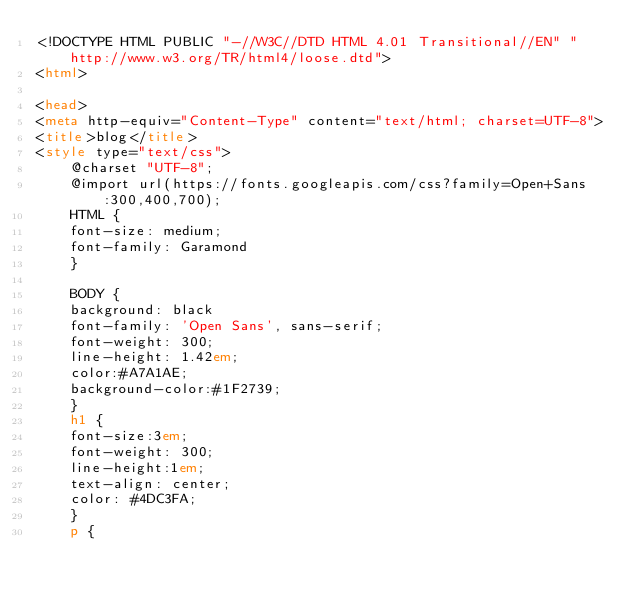<code> <loc_0><loc_0><loc_500><loc_500><_HTML_><!DOCTYPE HTML PUBLIC "-//W3C//DTD HTML 4.01 Transitional//EN" "http://www.w3.org/TR/html4/loose.dtd">
<html>

<head>
<meta http-equiv="Content-Type" content="text/html; charset=UTF-8">
<title>blog</title>
<style type="text/css">
    @charset "UTF-8";
    @import url(https://fonts.googleapis.com/css?family=Open+Sans:300,400,700);
    HTML {
    font-size: medium;
    font-family: Garamond
    }

    BODY {
    background: black
    font-family: 'Open Sans', sans-serif;
    font-weight: 300;
    line-height: 1.42em;
    color:#A7A1AE;
    background-color:#1F2739;
    }
    h1 {
    font-size:3em;
    font-weight: 300;
    line-height:1em;
    text-align: center;
    color: #4DC3FA;
    }
    p {</code> 